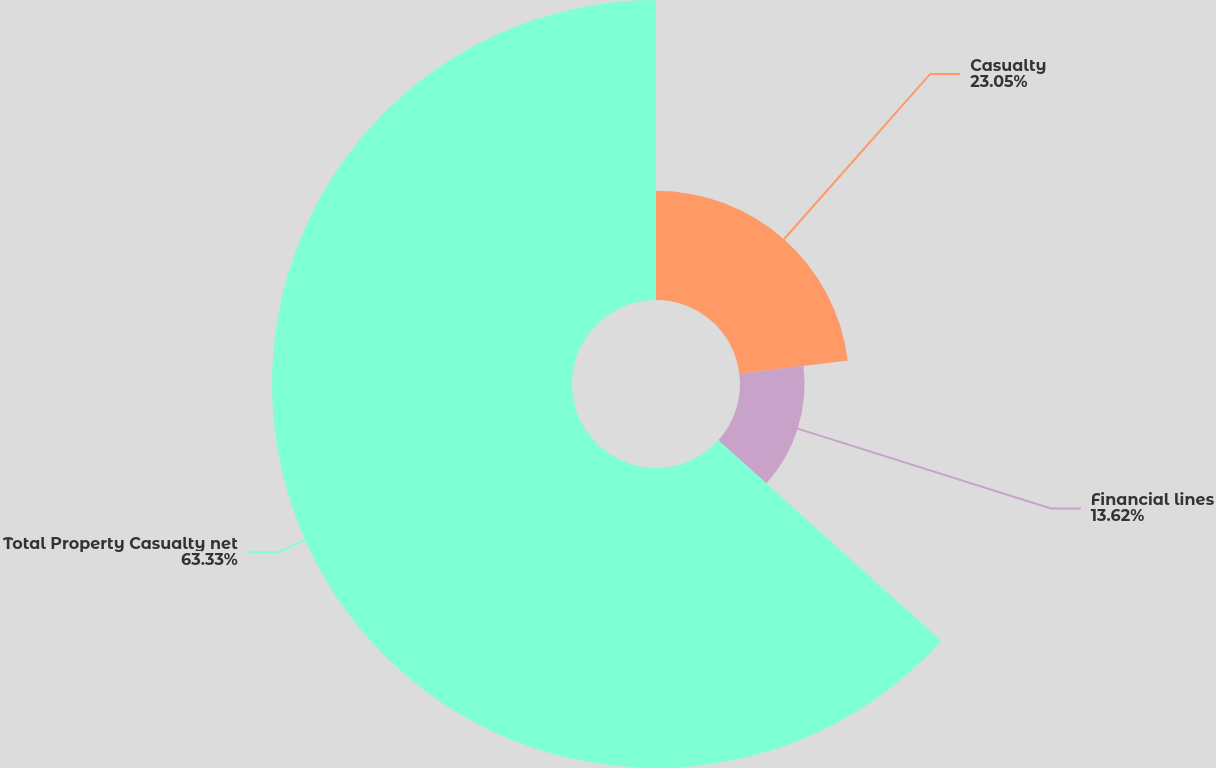<chart> <loc_0><loc_0><loc_500><loc_500><pie_chart><fcel>Casualty<fcel>Financial lines<fcel>Total Property Casualty net<nl><fcel>23.05%<fcel>13.62%<fcel>63.33%<nl></chart> 